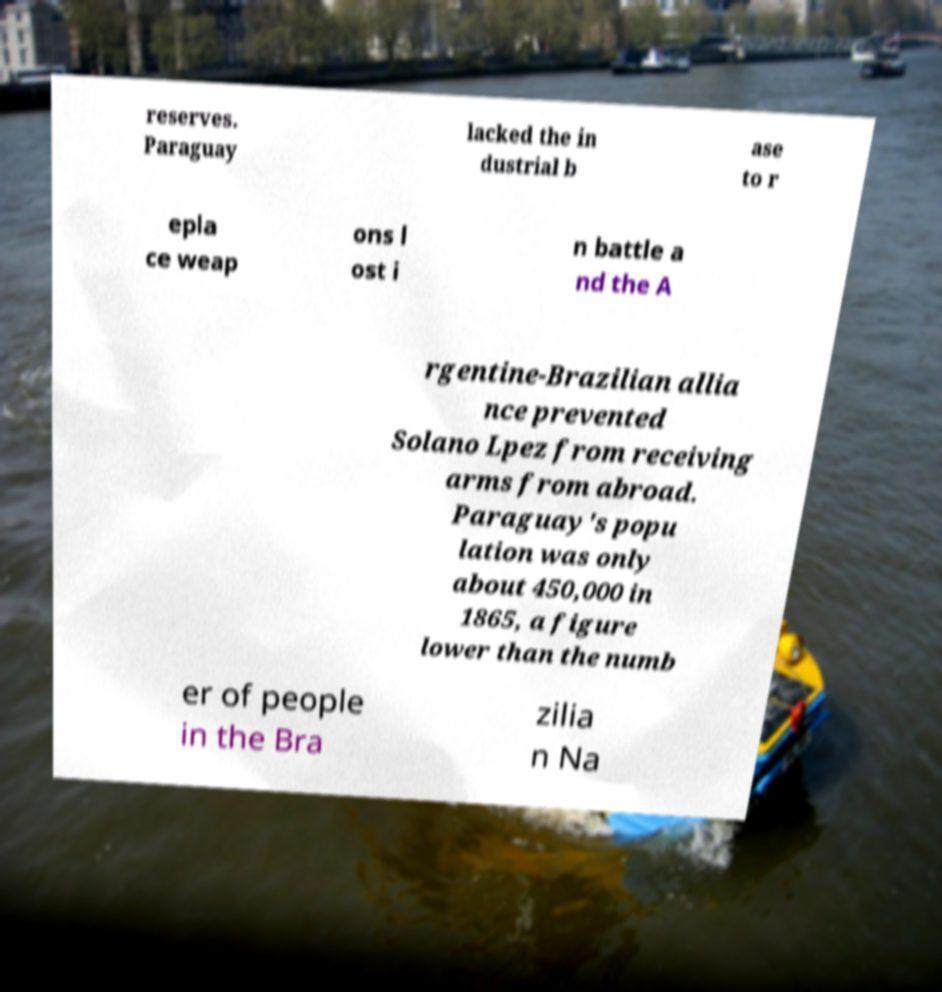Please read and relay the text visible in this image. What does it say? reserves. Paraguay lacked the in dustrial b ase to r epla ce weap ons l ost i n battle a nd the A rgentine-Brazilian allia nce prevented Solano Lpez from receiving arms from abroad. Paraguay's popu lation was only about 450,000 in 1865, a figure lower than the numb er of people in the Bra zilia n Na 